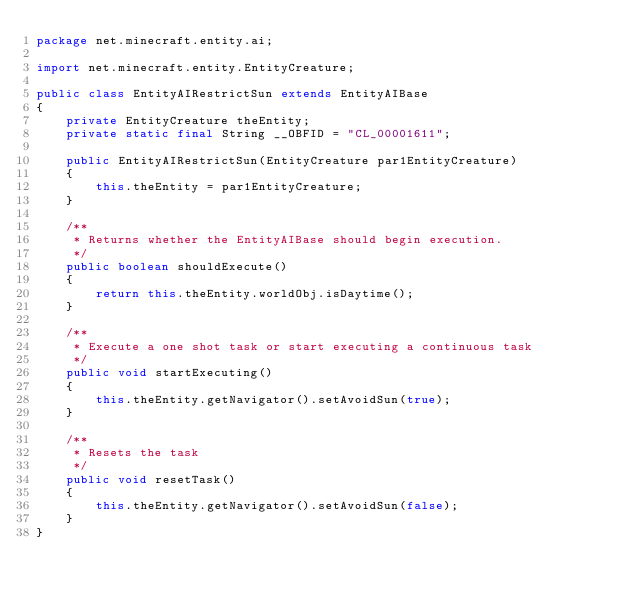<code> <loc_0><loc_0><loc_500><loc_500><_Java_>package net.minecraft.entity.ai;

import net.minecraft.entity.EntityCreature;

public class EntityAIRestrictSun extends EntityAIBase
{
    private EntityCreature theEntity;
    private static final String __OBFID = "CL_00001611";

    public EntityAIRestrictSun(EntityCreature par1EntityCreature)
    {
        this.theEntity = par1EntityCreature;
    }

    /**
     * Returns whether the EntityAIBase should begin execution.
     */
    public boolean shouldExecute()
    {
        return this.theEntity.worldObj.isDaytime();
    }

    /**
     * Execute a one shot task or start executing a continuous task
     */
    public void startExecuting()
    {
        this.theEntity.getNavigator().setAvoidSun(true);
    }

    /**
     * Resets the task
     */
    public void resetTask()
    {
        this.theEntity.getNavigator().setAvoidSun(false);
    }
}
</code> 